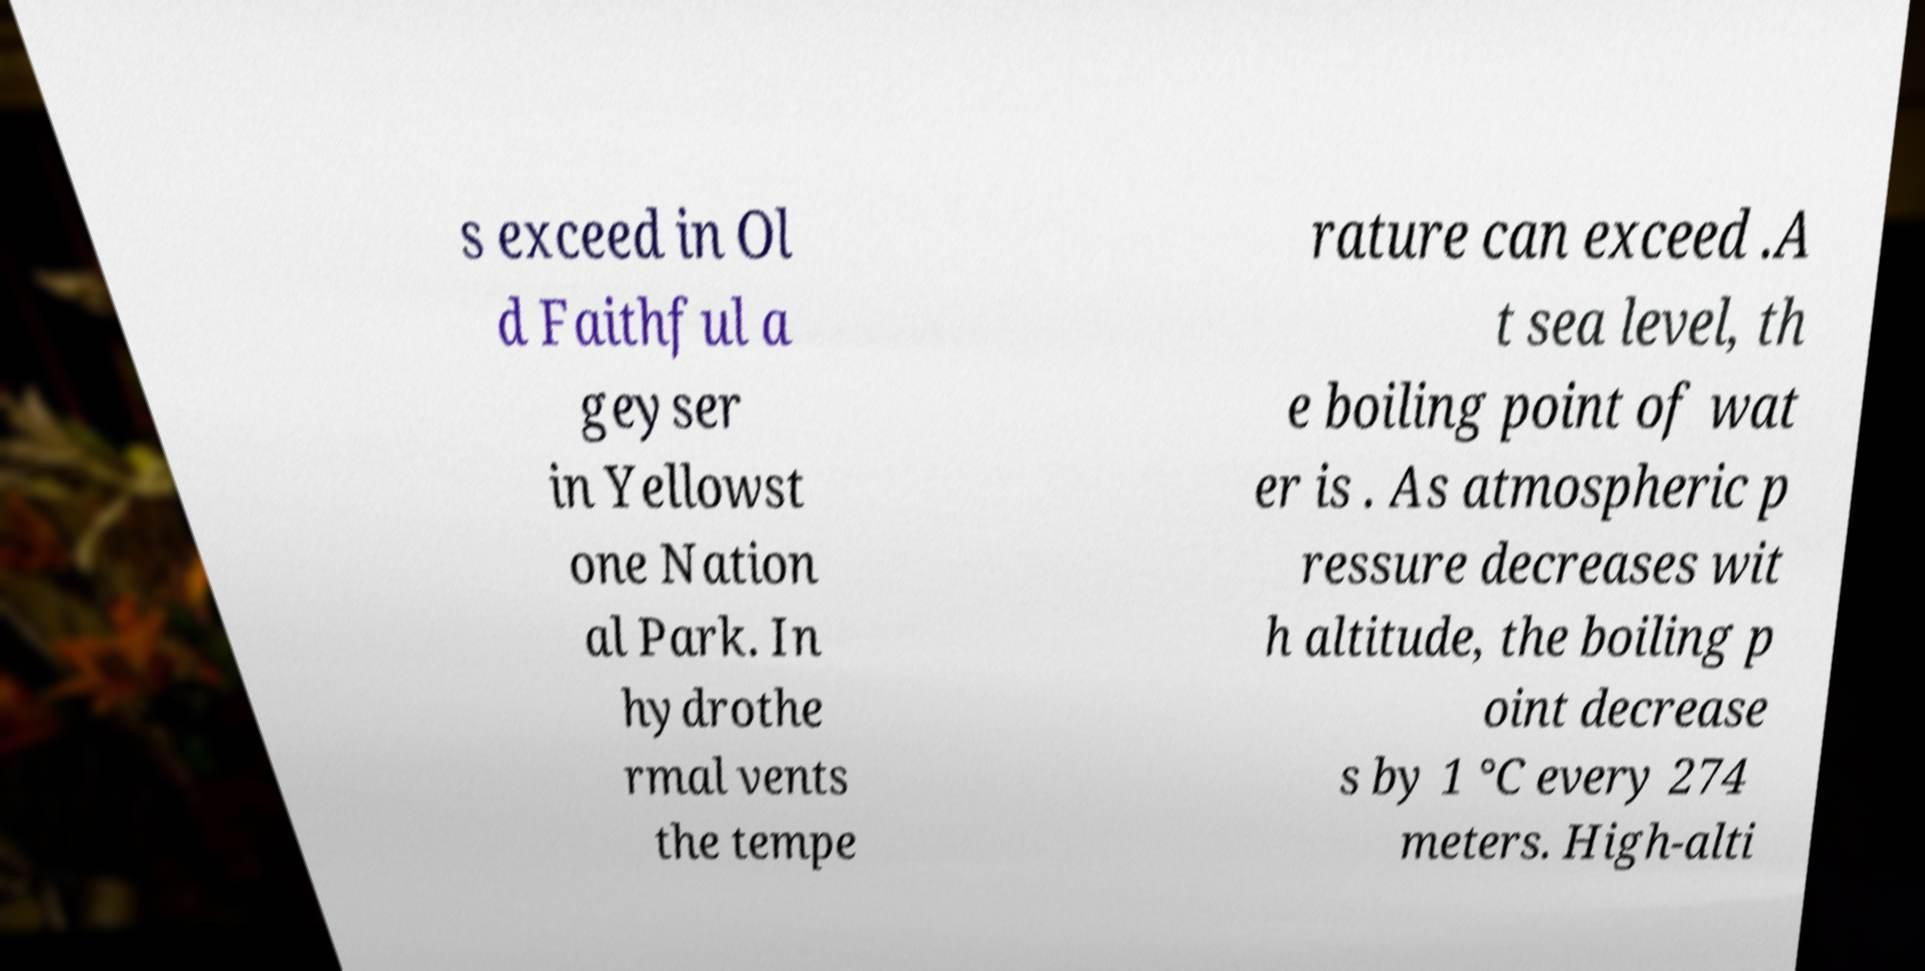Can you accurately transcribe the text from the provided image for me? s exceed in Ol d Faithful a geyser in Yellowst one Nation al Park. In hydrothe rmal vents the tempe rature can exceed .A t sea level, th e boiling point of wat er is . As atmospheric p ressure decreases wit h altitude, the boiling p oint decrease s by 1 °C every 274 meters. High-alti 